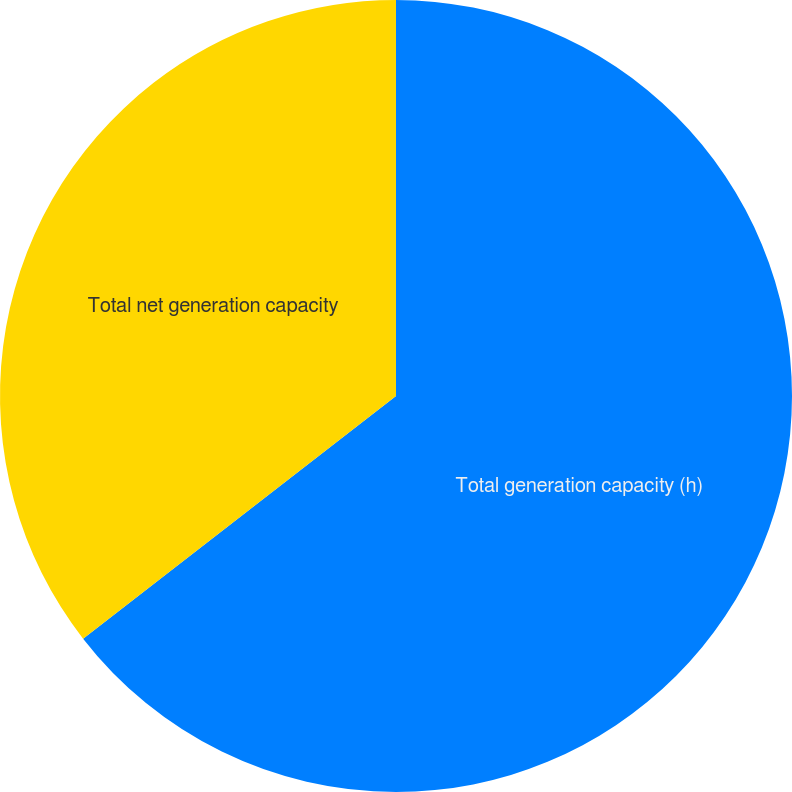Convert chart to OTSL. <chart><loc_0><loc_0><loc_500><loc_500><pie_chart><fcel>Total generation capacity (h)<fcel>Total net generation capacity<nl><fcel>64.5%<fcel>35.5%<nl></chart> 